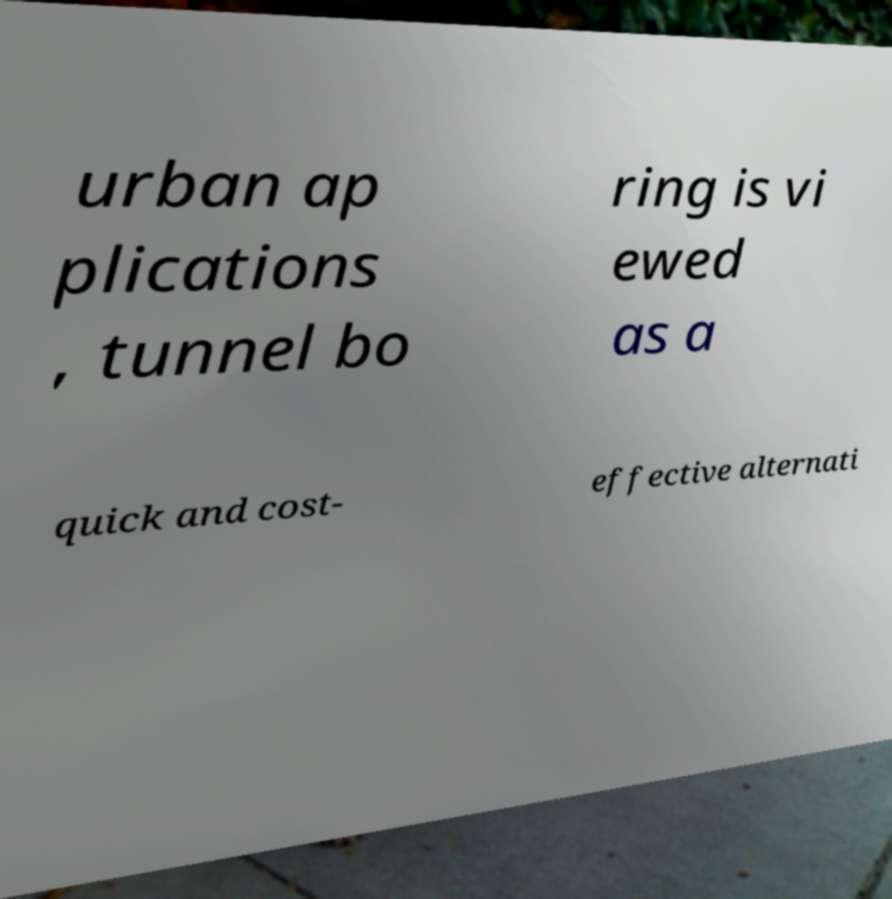There's text embedded in this image that I need extracted. Can you transcribe it verbatim? urban ap plications , tunnel bo ring is vi ewed as a quick and cost- effective alternati 